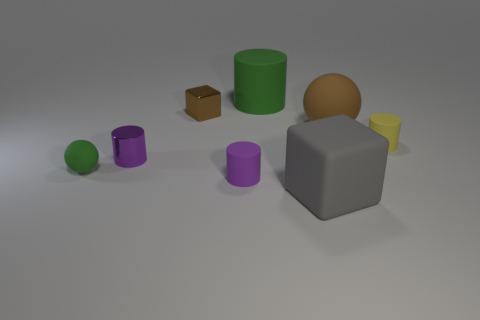Subtract all yellow rubber cylinders. How many cylinders are left? 3 Add 1 tiny matte balls. How many objects exist? 9 Subtract all red cubes. How many purple cylinders are left? 2 Subtract 1 cylinders. How many cylinders are left? 3 Subtract all spheres. How many objects are left? 6 Add 6 gray objects. How many gray objects exist? 7 Subtract all purple cylinders. How many cylinders are left? 2 Subtract 0 red cylinders. How many objects are left? 8 Subtract all cyan cubes. Subtract all brown cylinders. How many cubes are left? 2 Subtract all metal cylinders. Subtract all tiny cyan cylinders. How many objects are left? 7 